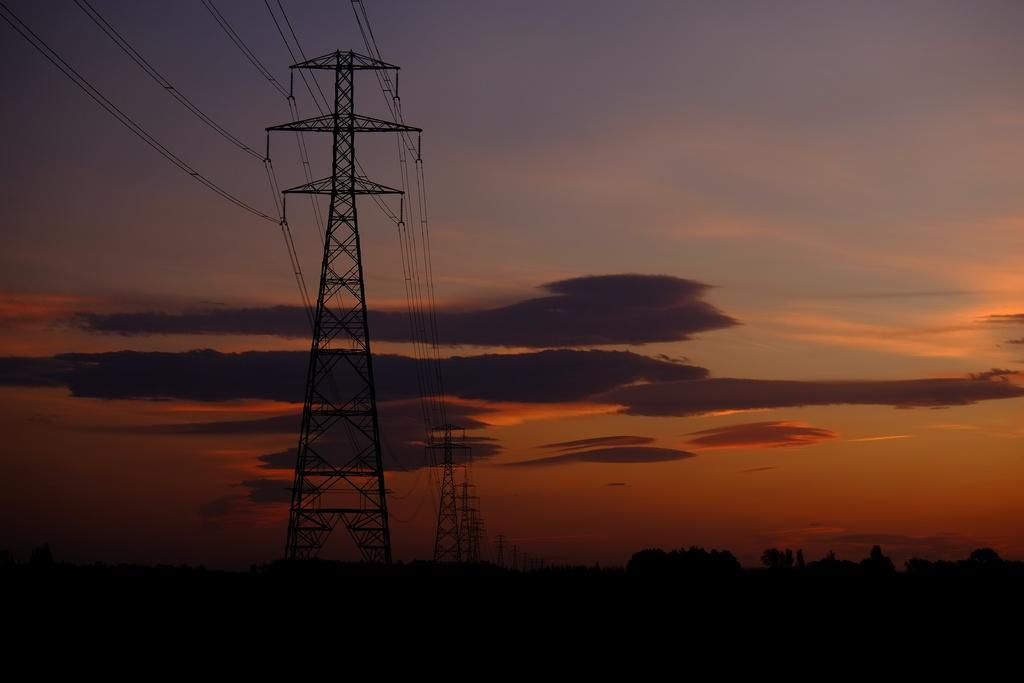In one or two sentences, can you explain what this image depicts? In this image we can see the towers with some wires. We can also see a group of trees and the sky which looks cloudy. 